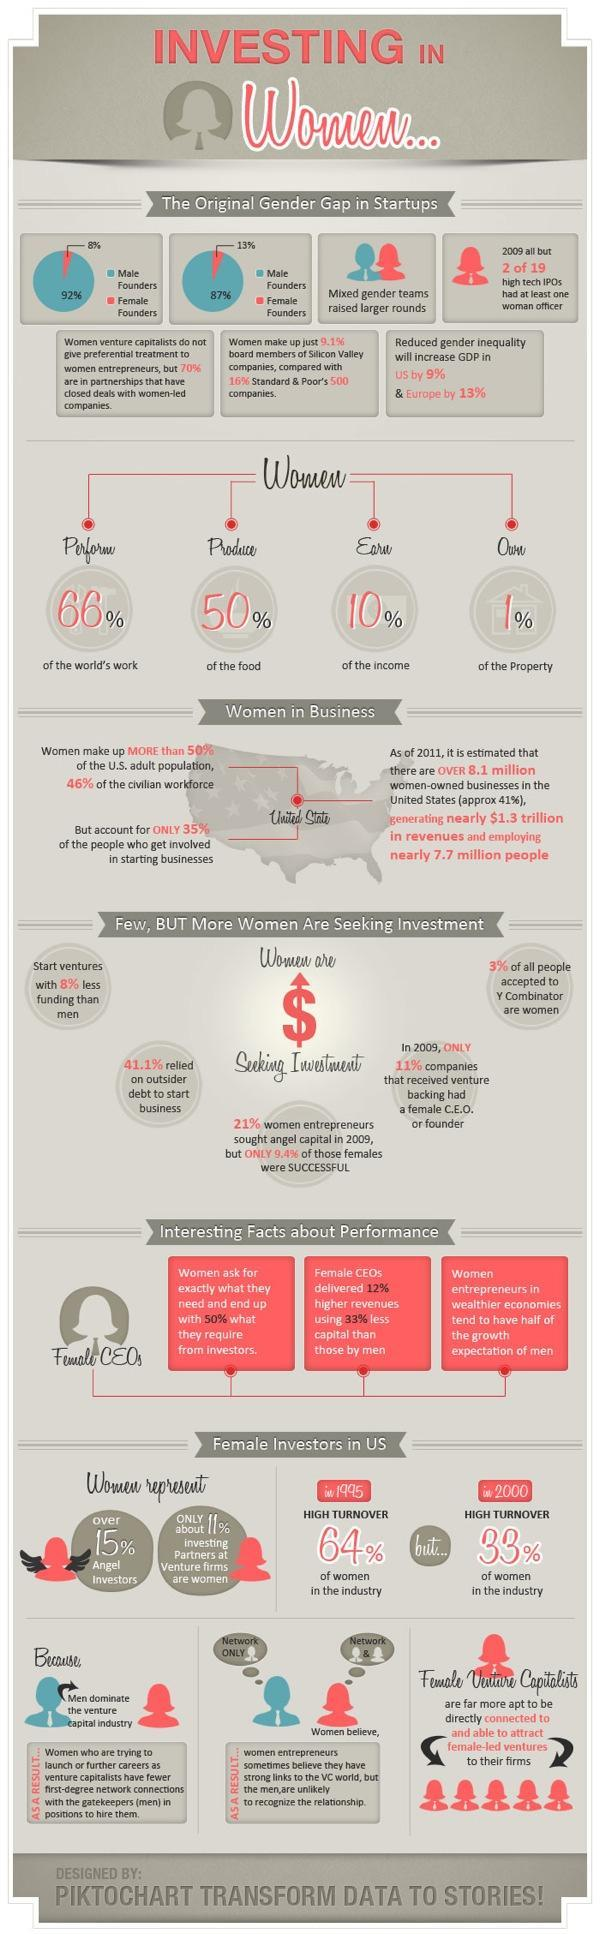How much % of angel investors are women
Answer the question with a short phrase. over 15% What is the % of property that women own 1% How much did the women turnover reduce in % in 2000 when compared to 1995 31 What % of the women who sought angel capital in 2009 were successful 90.6 What is the % of food that women produce 50% in 2009, what % of companies that received venture backing did not have a female CEO or founder 89 What is the % of of the world's work that women perform 66% 